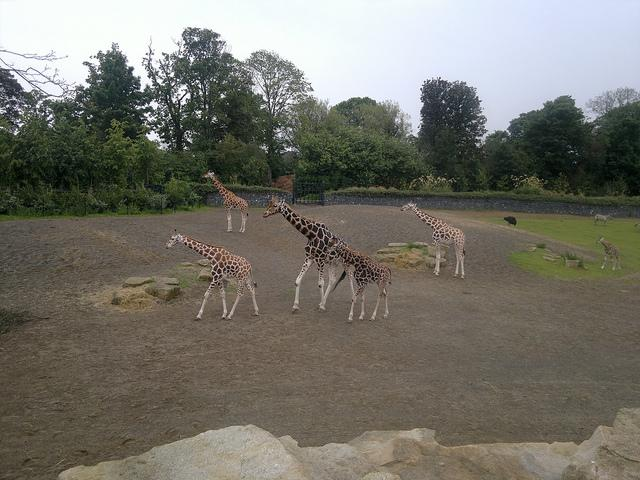What feature do the animals have? Please explain your reasoning. spots. This is obvious in the scene and entirely normal for giraffes. 